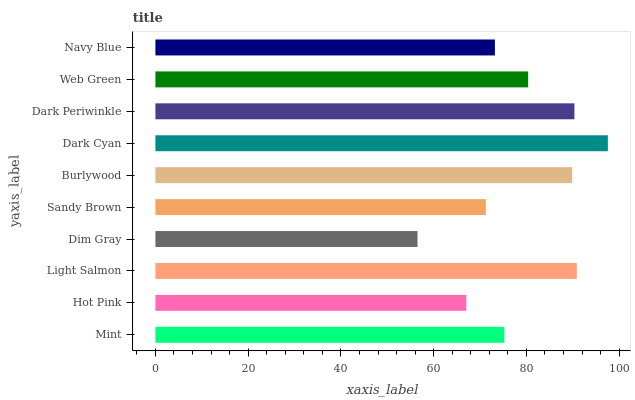Is Dim Gray the minimum?
Answer yes or no. Yes. Is Dark Cyan the maximum?
Answer yes or no. Yes. Is Hot Pink the minimum?
Answer yes or no. No. Is Hot Pink the maximum?
Answer yes or no. No. Is Mint greater than Hot Pink?
Answer yes or no. Yes. Is Hot Pink less than Mint?
Answer yes or no. Yes. Is Hot Pink greater than Mint?
Answer yes or no. No. Is Mint less than Hot Pink?
Answer yes or no. No. Is Web Green the high median?
Answer yes or no. Yes. Is Mint the low median?
Answer yes or no. Yes. Is Navy Blue the high median?
Answer yes or no. No. Is Burlywood the low median?
Answer yes or no. No. 